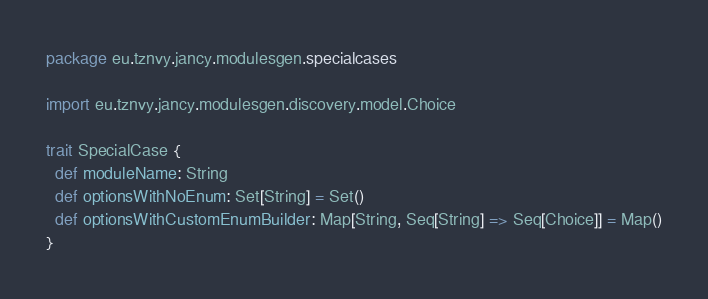<code> <loc_0><loc_0><loc_500><loc_500><_Scala_>package eu.tznvy.jancy.modulesgen.specialcases

import eu.tznvy.jancy.modulesgen.discovery.model.Choice

trait SpecialCase {
  def moduleName: String
  def optionsWithNoEnum: Set[String] = Set()
  def optionsWithCustomEnumBuilder: Map[String, Seq[String] => Seq[Choice]] = Map()
}
</code> 